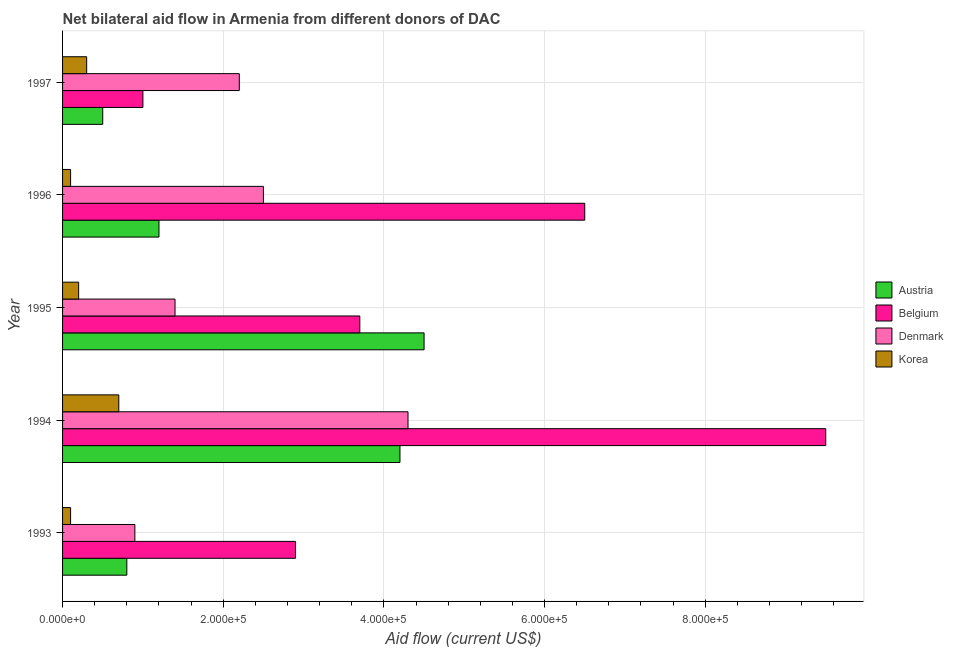How many different coloured bars are there?
Offer a terse response. 4. How many bars are there on the 1st tick from the bottom?
Offer a terse response. 4. What is the label of the 3rd group of bars from the top?
Make the answer very short. 1995. What is the amount of aid given by denmark in 1997?
Your answer should be compact. 2.20e+05. Across all years, what is the maximum amount of aid given by belgium?
Ensure brevity in your answer.  9.50e+05. Across all years, what is the minimum amount of aid given by denmark?
Ensure brevity in your answer.  9.00e+04. In which year was the amount of aid given by korea maximum?
Your answer should be compact. 1994. What is the total amount of aid given by austria in the graph?
Give a very brief answer. 1.12e+06. What is the difference between the amount of aid given by austria in 1995 and that in 1996?
Your answer should be compact. 3.30e+05. What is the difference between the amount of aid given by denmark in 1997 and the amount of aid given by belgium in 1995?
Your response must be concise. -1.50e+05. What is the average amount of aid given by belgium per year?
Ensure brevity in your answer.  4.72e+05. In the year 1996, what is the difference between the amount of aid given by denmark and amount of aid given by austria?
Offer a very short reply. 1.30e+05. What is the ratio of the amount of aid given by denmark in 1995 to that in 1997?
Provide a short and direct response. 0.64. What is the difference between the highest and the lowest amount of aid given by austria?
Offer a terse response. 4.00e+05. Is the sum of the amount of aid given by korea in 1993 and 1996 greater than the maximum amount of aid given by austria across all years?
Your response must be concise. No. Is it the case that in every year, the sum of the amount of aid given by denmark and amount of aid given by korea is greater than the sum of amount of aid given by austria and amount of aid given by belgium?
Give a very brief answer. Yes. What does the 3rd bar from the top in 1997 represents?
Your answer should be compact. Belgium. Is it the case that in every year, the sum of the amount of aid given by austria and amount of aid given by belgium is greater than the amount of aid given by denmark?
Make the answer very short. No. How many bars are there?
Offer a terse response. 20. Are all the bars in the graph horizontal?
Make the answer very short. Yes. How many legend labels are there?
Offer a very short reply. 4. What is the title of the graph?
Your response must be concise. Net bilateral aid flow in Armenia from different donors of DAC. Does "Secondary general education" appear as one of the legend labels in the graph?
Make the answer very short. No. What is the label or title of the Y-axis?
Your response must be concise. Year. What is the Aid flow (current US$) of Austria in 1993?
Provide a succinct answer. 8.00e+04. What is the Aid flow (current US$) of Belgium in 1994?
Ensure brevity in your answer.  9.50e+05. What is the Aid flow (current US$) of Korea in 1994?
Provide a short and direct response. 7.00e+04. What is the Aid flow (current US$) of Austria in 1995?
Your answer should be compact. 4.50e+05. What is the Aid flow (current US$) in Denmark in 1995?
Offer a terse response. 1.40e+05. What is the Aid flow (current US$) in Austria in 1996?
Make the answer very short. 1.20e+05. What is the Aid flow (current US$) of Belgium in 1996?
Give a very brief answer. 6.50e+05. What is the Aid flow (current US$) in Denmark in 1996?
Ensure brevity in your answer.  2.50e+05. What is the Aid flow (current US$) in Austria in 1997?
Ensure brevity in your answer.  5.00e+04. What is the Aid flow (current US$) in Belgium in 1997?
Ensure brevity in your answer.  1.00e+05. Across all years, what is the maximum Aid flow (current US$) in Austria?
Provide a short and direct response. 4.50e+05. Across all years, what is the maximum Aid flow (current US$) in Belgium?
Your answer should be compact. 9.50e+05. Across all years, what is the maximum Aid flow (current US$) of Denmark?
Give a very brief answer. 4.30e+05. Across all years, what is the maximum Aid flow (current US$) of Korea?
Keep it short and to the point. 7.00e+04. Across all years, what is the minimum Aid flow (current US$) of Austria?
Provide a succinct answer. 5.00e+04. Across all years, what is the minimum Aid flow (current US$) of Belgium?
Your response must be concise. 1.00e+05. Across all years, what is the minimum Aid flow (current US$) in Denmark?
Provide a succinct answer. 9.00e+04. What is the total Aid flow (current US$) in Austria in the graph?
Your answer should be compact. 1.12e+06. What is the total Aid flow (current US$) in Belgium in the graph?
Keep it short and to the point. 2.36e+06. What is the total Aid flow (current US$) in Denmark in the graph?
Provide a succinct answer. 1.13e+06. What is the difference between the Aid flow (current US$) of Belgium in 1993 and that in 1994?
Keep it short and to the point. -6.60e+05. What is the difference between the Aid flow (current US$) of Denmark in 1993 and that in 1994?
Offer a terse response. -3.40e+05. What is the difference between the Aid flow (current US$) of Austria in 1993 and that in 1995?
Offer a very short reply. -3.70e+05. What is the difference between the Aid flow (current US$) of Belgium in 1993 and that in 1995?
Provide a short and direct response. -8.00e+04. What is the difference between the Aid flow (current US$) in Denmark in 1993 and that in 1995?
Offer a very short reply. -5.00e+04. What is the difference between the Aid flow (current US$) of Belgium in 1993 and that in 1996?
Give a very brief answer. -3.60e+05. What is the difference between the Aid flow (current US$) of Austria in 1993 and that in 1997?
Provide a short and direct response. 3.00e+04. What is the difference between the Aid flow (current US$) of Belgium in 1993 and that in 1997?
Provide a succinct answer. 1.90e+05. What is the difference between the Aid flow (current US$) of Denmark in 1993 and that in 1997?
Offer a very short reply. -1.30e+05. What is the difference between the Aid flow (current US$) in Belgium in 1994 and that in 1995?
Offer a very short reply. 5.80e+05. What is the difference between the Aid flow (current US$) in Austria in 1994 and that in 1996?
Your response must be concise. 3.00e+05. What is the difference between the Aid flow (current US$) of Belgium in 1994 and that in 1996?
Provide a short and direct response. 3.00e+05. What is the difference between the Aid flow (current US$) of Denmark in 1994 and that in 1996?
Give a very brief answer. 1.80e+05. What is the difference between the Aid flow (current US$) of Belgium in 1994 and that in 1997?
Provide a short and direct response. 8.50e+05. What is the difference between the Aid flow (current US$) of Austria in 1995 and that in 1996?
Offer a very short reply. 3.30e+05. What is the difference between the Aid flow (current US$) in Belgium in 1995 and that in 1996?
Offer a very short reply. -2.80e+05. What is the difference between the Aid flow (current US$) of Korea in 1995 and that in 1996?
Offer a very short reply. 10000. What is the difference between the Aid flow (current US$) of Belgium in 1995 and that in 1997?
Provide a short and direct response. 2.70e+05. What is the difference between the Aid flow (current US$) of Denmark in 1995 and that in 1997?
Provide a short and direct response. -8.00e+04. What is the difference between the Aid flow (current US$) of Austria in 1996 and that in 1997?
Offer a terse response. 7.00e+04. What is the difference between the Aid flow (current US$) in Belgium in 1996 and that in 1997?
Your answer should be compact. 5.50e+05. What is the difference between the Aid flow (current US$) in Austria in 1993 and the Aid flow (current US$) in Belgium in 1994?
Provide a short and direct response. -8.70e+05. What is the difference between the Aid flow (current US$) of Austria in 1993 and the Aid flow (current US$) of Denmark in 1994?
Provide a short and direct response. -3.50e+05. What is the difference between the Aid flow (current US$) in Austria in 1993 and the Aid flow (current US$) in Korea in 1994?
Offer a very short reply. 10000. What is the difference between the Aid flow (current US$) in Belgium in 1993 and the Aid flow (current US$) in Korea in 1994?
Provide a short and direct response. 2.20e+05. What is the difference between the Aid flow (current US$) of Denmark in 1993 and the Aid flow (current US$) of Korea in 1994?
Provide a succinct answer. 2.00e+04. What is the difference between the Aid flow (current US$) of Austria in 1993 and the Aid flow (current US$) of Denmark in 1995?
Offer a terse response. -6.00e+04. What is the difference between the Aid flow (current US$) in Austria in 1993 and the Aid flow (current US$) in Korea in 1995?
Provide a short and direct response. 6.00e+04. What is the difference between the Aid flow (current US$) of Belgium in 1993 and the Aid flow (current US$) of Korea in 1995?
Your response must be concise. 2.70e+05. What is the difference between the Aid flow (current US$) of Austria in 1993 and the Aid flow (current US$) of Belgium in 1996?
Offer a terse response. -5.70e+05. What is the difference between the Aid flow (current US$) of Austria in 1993 and the Aid flow (current US$) of Korea in 1996?
Provide a short and direct response. 7.00e+04. What is the difference between the Aid flow (current US$) in Belgium in 1993 and the Aid flow (current US$) in Denmark in 1996?
Offer a very short reply. 4.00e+04. What is the difference between the Aid flow (current US$) of Belgium in 1993 and the Aid flow (current US$) of Korea in 1996?
Provide a succinct answer. 2.80e+05. What is the difference between the Aid flow (current US$) of Denmark in 1993 and the Aid flow (current US$) of Korea in 1996?
Your answer should be compact. 8.00e+04. What is the difference between the Aid flow (current US$) in Denmark in 1993 and the Aid flow (current US$) in Korea in 1997?
Ensure brevity in your answer.  6.00e+04. What is the difference between the Aid flow (current US$) in Austria in 1994 and the Aid flow (current US$) in Belgium in 1995?
Offer a very short reply. 5.00e+04. What is the difference between the Aid flow (current US$) in Austria in 1994 and the Aid flow (current US$) in Denmark in 1995?
Provide a short and direct response. 2.80e+05. What is the difference between the Aid flow (current US$) of Austria in 1994 and the Aid flow (current US$) of Korea in 1995?
Offer a very short reply. 4.00e+05. What is the difference between the Aid flow (current US$) in Belgium in 1994 and the Aid flow (current US$) in Denmark in 1995?
Offer a terse response. 8.10e+05. What is the difference between the Aid flow (current US$) of Belgium in 1994 and the Aid flow (current US$) of Korea in 1995?
Keep it short and to the point. 9.30e+05. What is the difference between the Aid flow (current US$) of Austria in 1994 and the Aid flow (current US$) of Belgium in 1996?
Offer a very short reply. -2.30e+05. What is the difference between the Aid flow (current US$) in Austria in 1994 and the Aid flow (current US$) in Korea in 1996?
Provide a short and direct response. 4.10e+05. What is the difference between the Aid flow (current US$) in Belgium in 1994 and the Aid flow (current US$) in Korea in 1996?
Give a very brief answer. 9.40e+05. What is the difference between the Aid flow (current US$) in Belgium in 1994 and the Aid flow (current US$) in Denmark in 1997?
Your response must be concise. 7.30e+05. What is the difference between the Aid flow (current US$) of Belgium in 1994 and the Aid flow (current US$) of Korea in 1997?
Your answer should be very brief. 9.20e+05. What is the difference between the Aid flow (current US$) in Austria in 1995 and the Aid flow (current US$) in Belgium in 1996?
Make the answer very short. -2.00e+05. What is the difference between the Aid flow (current US$) of Austria in 1995 and the Aid flow (current US$) of Denmark in 1996?
Your response must be concise. 2.00e+05. What is the difference between the Aid flow (current US$) in Belgium in 1995 and the Aid flow (current US$) in Korea in 1996?
Provide a succinct answer. 3.60e+05. What is the difference between the Aid flow (current US$) of Austria in 1995 and the Aid flow (current US$) of Denmark in 1997?
Offer a very short reply. 2.30e+05. What is the difference between the Aid flow (current US$) in Austria in 1995 and the Aid flow (current US$) in Korea in 1997?
Offer a very short reply. 4.20e+05. What is the difference between the Aid flow (current US$) of Belgium in 1995 and the Aid flow (current US$) of Korea in 1997?
Keep it short and to the point. 3.40e+05. What is the difference between the Aid flow (current US$) in Denmark in 1995 and the Aid flow (current US$) in Korea in 1997?
Give a very brief answer. 1.10e+05. What is the difference between the Aid flow (current US$) of Austria in 1996 and the Aid flow (current US$) of Belgium in 1997?
Offer a very short reply. 2.00e+04. What is the difference between the Aid flow (current US$) of Austria in 1996 and the Aid flow (current US$) of Denmark in 1997?
Offer a terse response. -1.00e+05. What is the difference between the Aid flow (current US$) in Belgium in 1996 and the Aid flow (current US$) in Denmark in 1997?
Give a very brief answer. 4.30e+05. What is the difference between the Aid flow (current US$) in Belgium in 1996 and the Aid flow (current US$) in Korea in 1997?
Ensure brevity in your answer.  6.20e+05. What is the difference between the Aid flow (current US$) in Denmark in 1996 and the Aid flow (current US$) in Korea in 1997?
Your answer should be very brief. 2.20e+05. What is the average Aid flow (current US$) in Austria per year?
Give a very brief answer. 2.24e+05. What is the average Aid flow (current US$) of Belgium per year?
Provide a short and direct response. 4.72e+05. What is the average Aid flow (current US$) of Denmark per year?
Provide a short and direct response. 2.26e+05. What is the average Aid flow (current US$) in Korea per year?
Your response must be concise. 2.80e+04. In the year 1993, what is the difference between the Aid flow (current US$) of Austria and Aid flow (current US$) of Belgium?
Offer a very short reply. -2.10e+05. In the year 1993, what is the difference between the Aid flow (current US$) in Austria and Aid flow (current US$) in Korea?
Your answer should be very brief. 7.00e+04. In the year 1993, what is the difference between the Aid flow (current US$) in Denmark and Aid flow (current US$) in Korea?
Give a very brief answer. 8.00e+04. In the year 1994, what is the difference between the Aid flow (current US$) of Austria and Aid flow (current US$) of Belgium?
Provide a succinct answer. -5.30e+05. In the year 1994, what is the difference between the Aid flow (current US$) in Belgium and Aid flow (current US$) in Denmark?
Your response must be concise. 5.20e+05. In the year 1994, what is the difference between the Aid flow (current US$) of Belgium and Aid flow (current US$) of Korea?
Your answer should be compact. 8.80e+05. In the year 1994, what is the difference between the Aid flow (current US$) in Denmark and Aid flow (current US$) in Korea?
Give a very brief answer. 3.60e+05. In the year 1995, what is the difference between the Aid flow (current US$) of Belgium and Aid flow (current US$) of Denmark?
Ensure brevity in your answer.  2.30e+05. In the year 1995, what is the difference between the Aid flow (current US$) of Denmark and Aid flow (current US$) of Korea?
Your answer should be compact. 1.20e+05. In the year 1996, what is the difference between the Aid flow (current US$) of Austria and Aid flow (current US$) of Belgium?
Make the answer very short. -5.30e+05. In the year 1996, what is the difference between the Aid flow (current US$) in Austria and Aid flow (current US$) in Denmark?
Make the answer very short. -1.30e+05. In the year 1996, what is the difference between the Aid flow (current US$) in Austria and Aid flow (current US$) in Korea?
Provide a succinct answer. 1.10e+05. In the year 1996, what is the difference between the Aid flow (current US$) in Belgium and Aid flow (current US$) in Korea?
Ensure brevity in your answer.  6.40e+05. In the year 1996, what is the difference between the Aid flow (current US$) of Denmark and Aid flow (current US$) of Korea?
Your answer should be compact. 2.40e+05. In the year 1997, what is the difference between the Aid flow (current US$) of Austria and Aid flow (current US$) of Korea?
Ensure brevity in your answer.  2.00e+04. What is the ratio of the Aid flow (current US$) of Austria in 1993 to that in 1994?
Provide a succinct answer. 0.19. What is the ratio of the Aid flow (current US$) of Belgium in 1993 to that in 1994?
Offer a terse response. 0.31. What is the ratio of the Aid flow (current US$) in Denmark in 1993 to that in 1994?
Make the answer very short. 0.21. What is the ratio of the Aid flow (current US$) of Korea in 1993 to that in 1994?
Keep it short and to the point. 0.14. What is the ratio of the Aid flow (current US$) in Austria in 1993 to that in 1995?
Your answer should be very brief. 0.18. What is the ratio of the Aid flow (current US$) in Belgium in 1993 to that in 1995?
Your response must be concise. 0.78. What is the ratio of the Aid flow (current US$) in Denmark in 1993 to that in 1995?
Your answer should be compact. 0.64. What is the ratio of the Aid flow (current US$) of Korea in 1993 to that in 1995?
Provide a short and direct response. 0.5. What is the ratio of the Aid flow (current US$) of Belgium in 1993 to that in 1996?
Your answer should be compact. 0.45. What is the ratio of the Aid flow (current US$) of Denmark in 1993 to that in 1996?
Your answer should be very brief. 0.36. What is the ratio of the Aid flow (current US$) in Korea in 1993 to that in 1996?
Keep it short and to the point. 1. What is the ratio of the Aid flow (current US$) in Denmark in 1993 to that in 1997?
Your answer should be compact. 0.41. What is the ratio of the Aid flow (current US$) in Korea in 1993 to that in 1997?
Provide a succinct answer. 0.33. What is the ratio of the Aid flow (current US$) in Belgium in 1994 to that in 1995?
Offer a very short reply. 2.57. What is the ratio of the Aid flow (current US$) in Denmark in 1994 to that in 1995?
Offer a very short reply. 3.07. What is the ratio of the Aid flow (current US$) of Austria in 1994 to that in 1996?
Keep it short and to the point. 3.5. What is the ratio of the Aid flow (current US$) in Belgium in 1994 to that in 1996?
Give a very brief answer. 1.46. What is the ratio of the Aid flow (current US$) of Denmark in 1994 to that in 1996?
Provide a succinct answer. 1.72. What is the ratio of the Aid flow (current US$) of Korea in 1994 to that in 1996?
Provide a short and direct response. 7. What is the ratio of the Aid flow (current US$) of Denmark in 1994 to that in 1997?
Offer a very short reply. 1.95. What is the ratio of the Aid flow (current US$) in Korea in 1994 to that in 1997?
Offer a terse response. 2.33. What is the ratio of the Aid flow (current US$) of Austria in 1995 to that in 1996?
Provide a short and direct response. 3.75. What is the ratio of the Aid flow (current US$) in Belgium in 1995 to that in 1996?
Your answer should be compact. 0.57. What is the ratio of the Aid flow (current US$) in Denmark in 1995 to that in 1996?
Offer a terse response. 0.56. What is the ratio of the Aid flow (current US$) of Denmark in 1995 to that in 1997?
Give a very brief answer. 0.64. What is the ratio of the Aid flow (current US$) of Korea in 1995 to that in 1997?
Your answer should be very brief. 0.67. What is the ratio of the Aid flow (current US$) in Austria in 1996 to that in 1997?
Offer a terse response. 2.4. What is the ratio of the Aid flow (current US$) of Belgium in 1996 to that in 1997?
Give a very brief answer. 6.5. What is the ratio of the Aid flow (current US$) in Denmark in 1996 to that in 1997?
Offer a terse response. 1.14. What is the difference between the highest and the second highest Aid flow (current US$) of Denmark?
Keep it short and to the point. 1.80e+05. What is the difference between the highest and the lowest Aid flow (current US$) of Belgium?
Your response must be concise. 8.50e+05. What is the difference between the highest and the lowest Aid flow (current US$) of Korea?
Your answer should be compact. 6.00e+04. 